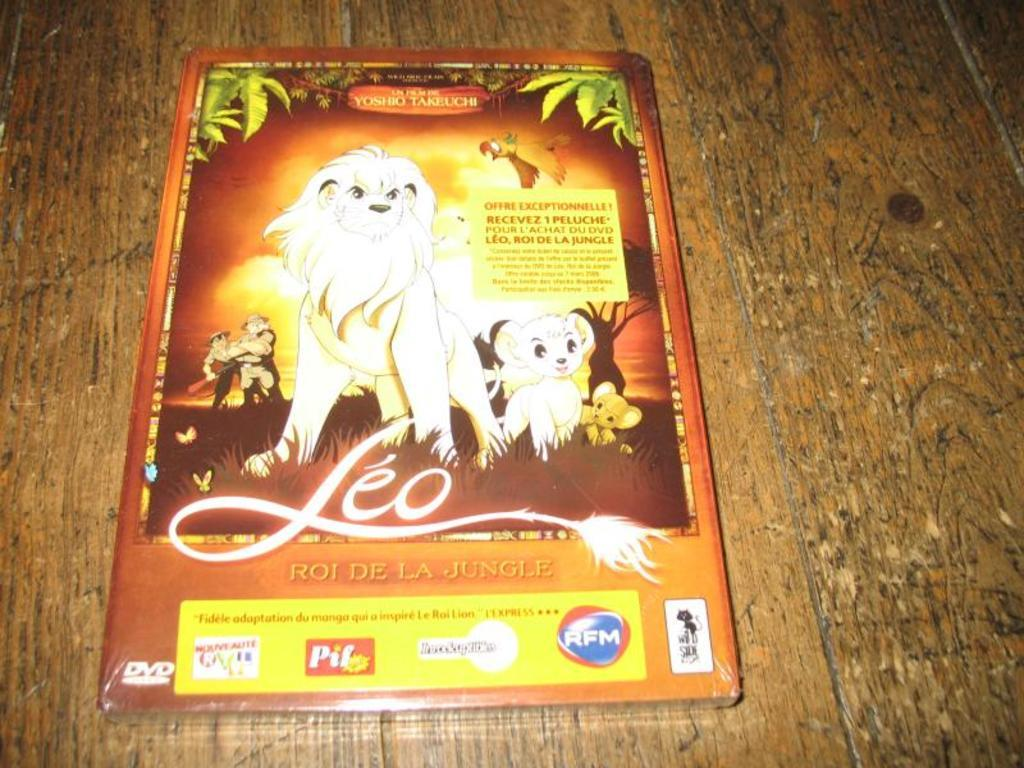What color is the main object in the image? The main object in the image is brown-colored. What is depicted on the brown-colored object? There are cartoons on the brown-colored object. Is there any text present on the brown-colored object? Yes, there is text written on the brown-colored object. What is the size of the sheet used to cover the brown-colored object in the image? There is no sheet present in the image, and the brown-colored object is not covered. 